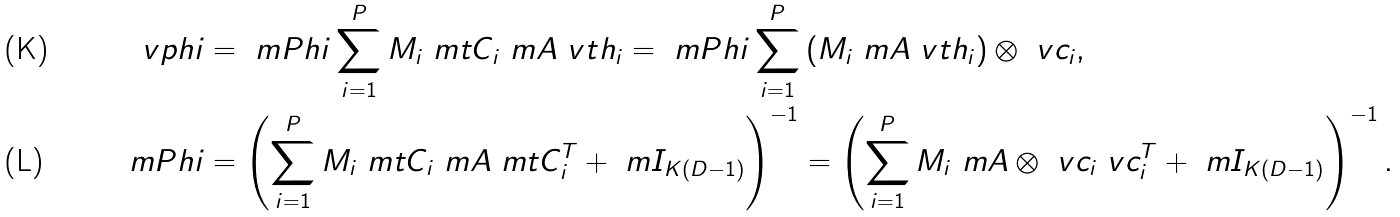Convert formula to latex. <formula><loc_0><loc_0><loc_500><loc_500>\ v p h i & = \ m P h i \sum _ { i = 1 } ^ { P } M _ { i } \ m t C _ { i } \ m A \ v t h _ { i } = \ m P h i \sum _ { i = 1 } ^ { P } \left ( M _ { i } \ m A \ v t h _ { i } \right ) \otimes \ v c _ { i } , \\ \ m P h i & = \left ( \sum _ { i = 1 } ^ { P } M _ { i } \ m t C _ { i } \ m A \ m t C _ { i } ^ { T } + \ m I _ { K ( D - 1 ) } \right ) ^ { - 1 } = \left ( \sum _ { i = 1 } ^ { P } M _ { i } \ m A \otimes \ v c _ { i } \ v c _ { i } ^ { T } + \ m I _ { K ( D - 1 ) } \right ) ^ { - 1 } .</formula> 